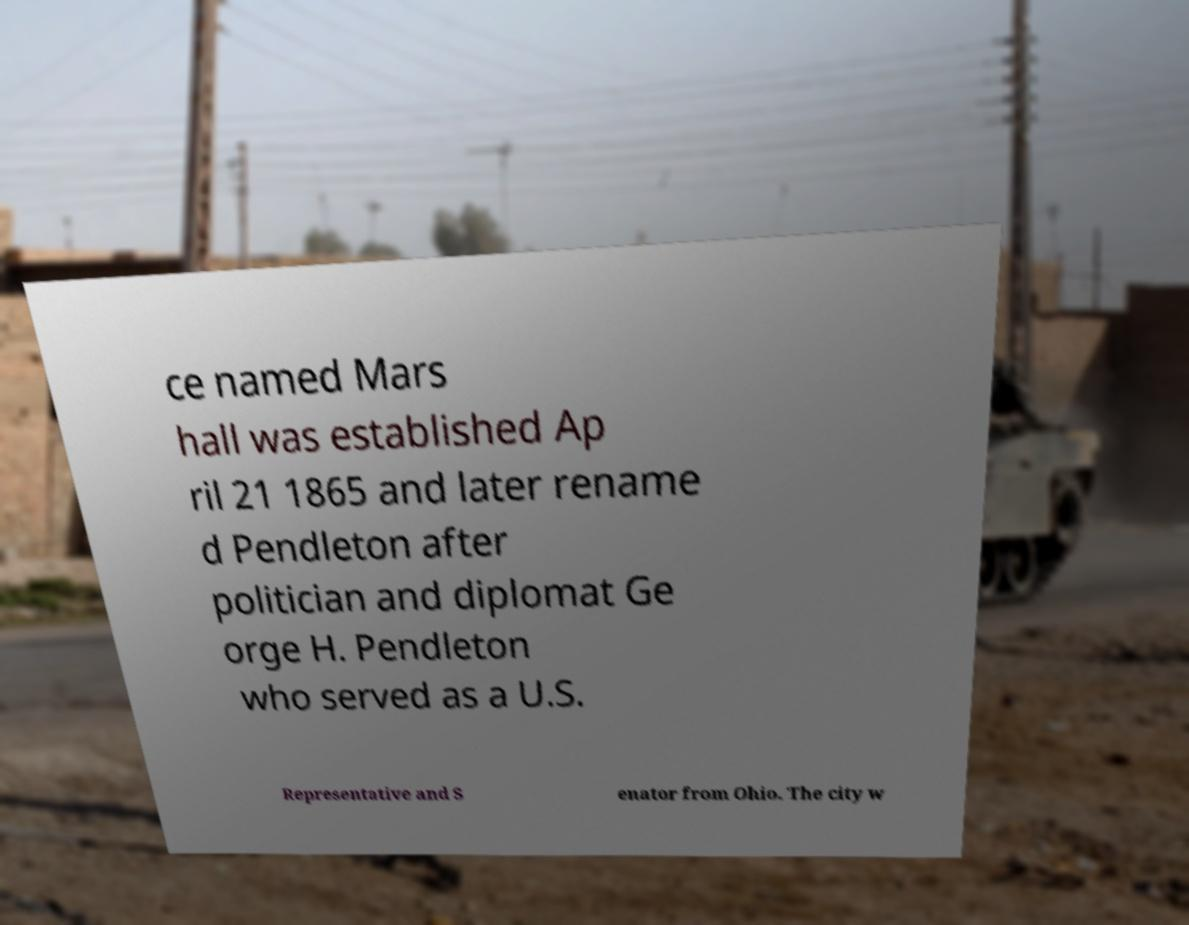Can you accurately transcribe the text from the provided image for me? ce named Mars hall was established Ap ril 21 1865 and later rename d Pendleton after politician and diplomat Ge orge H. Pendleton who served as a U.S. Representative and S enator from Ohio. The city w 